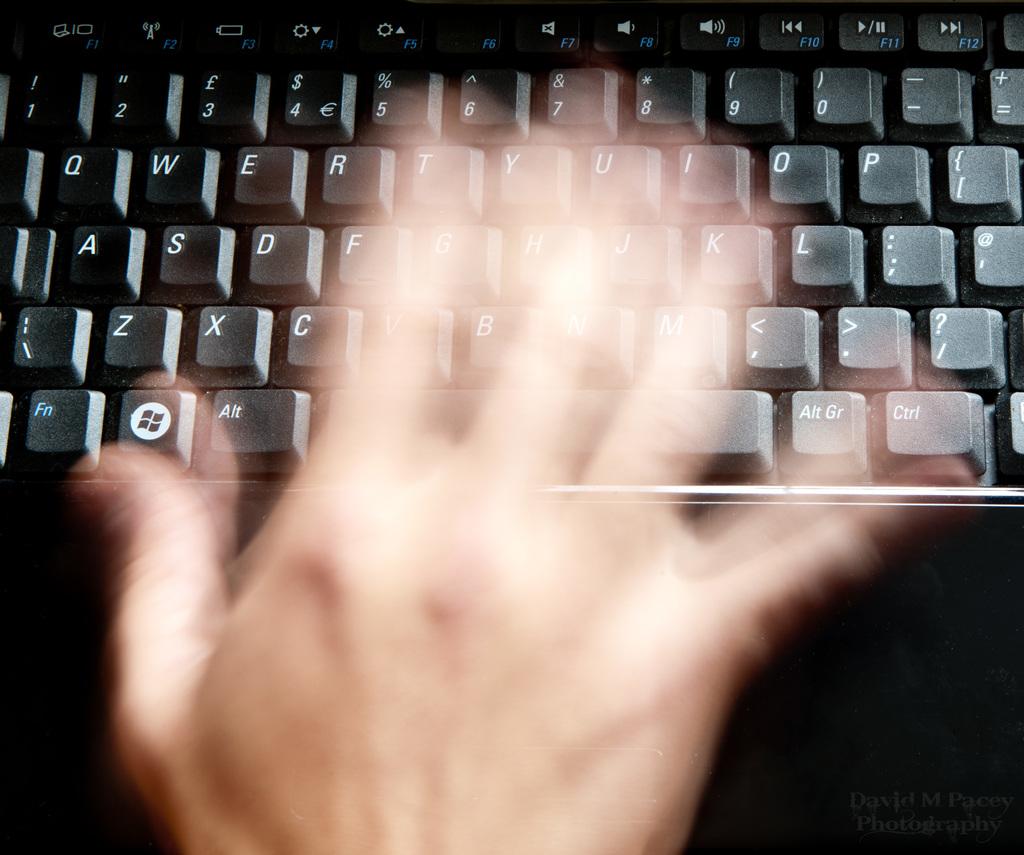What is the first letter in the top row?
Ensure brevity in your answer.  Q. 